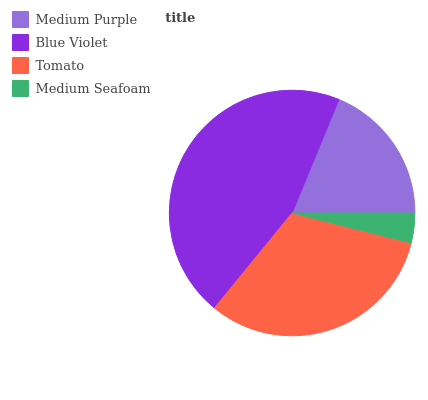Is Medium Seafoam the minimum?
Answer yes or no. Yes. Is Blue Violet the maximum?
Answer yes or no. Yes. Is Tomato the minimum?
Answer yes or no. No. Is Tomato the maximum?
Answer yes or no. No. Is Blue Violet greater than Tomato?
Answer yes or no. Yes. Is Tomato less than Blue Violet?
Answer yes or no. Yes. Is Tomato greater than Blue Violet?
Answer yes or no. No. Is Blue Violet less than Tomato?
Answer yes or no. No. Is Tomato the high median?
Answer yes or no. Yes. Is Medium Purple the low median?
Answer yes or no. Yes. Is Blue Violet the high median?
Answer yes or no. No. Is Blue Violet the low median?
Answer yes or no. No. 